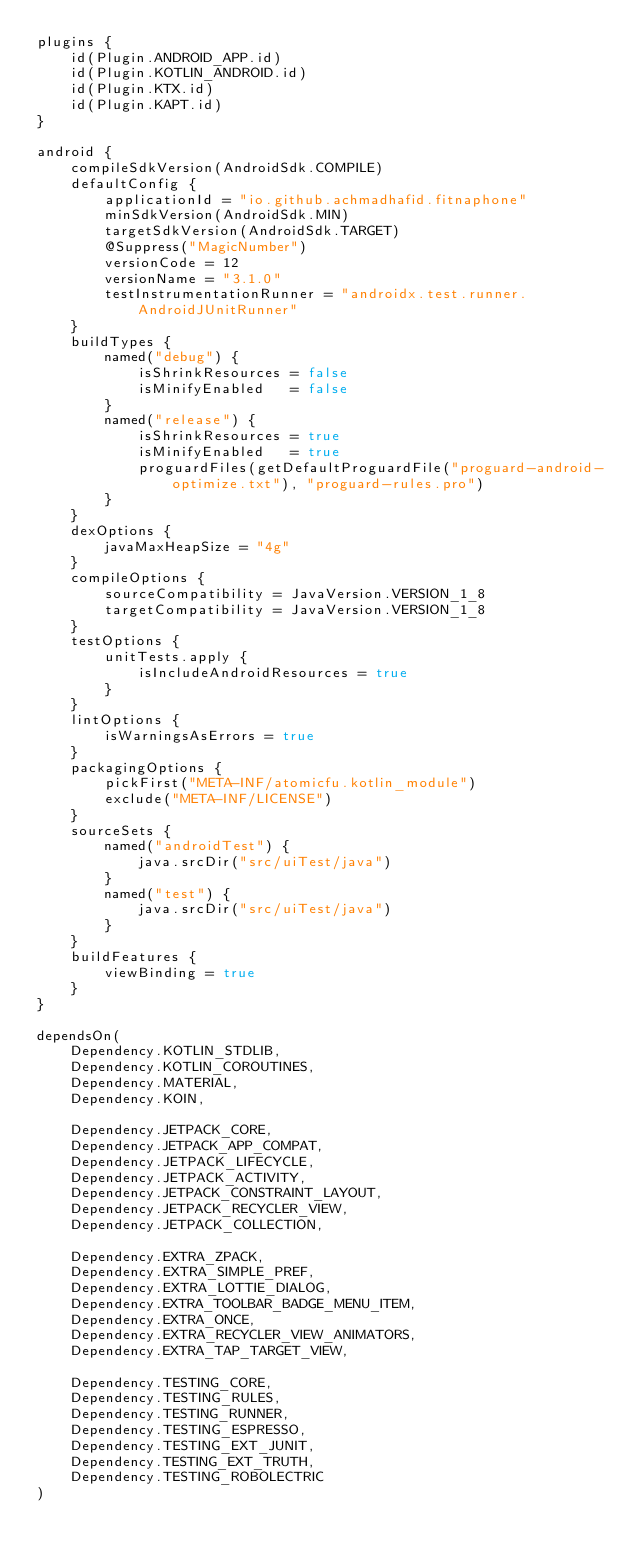Convert code to text. <code><loc_0><loc_0><loc_500><loc_500><_Kotlin_>plugins {
    id(Plugin.ANDROID_APP.id)
    id(Plugin.KOTLIN_ANDROID.id)
    id(Plugin.KTX.id)
    id(Plugin.KAPT.id)
}

android {
    compileSdkVersion(AndroidSdk.COMPILE)
    defaultConfig {
        applicationId = "io.github.achmadhafid.fitnaphone"
        minSdkVersion(AndroidSdk.MIN)
        targetSdkVersion(AndroidSdk.TARGET)
        @Suppress("MagicNumber")
        versionCode = 12
        versionName = "3.1.0"
        testInstrumentationRunner = "androidx.test.runner.AndroidJUnitRunner"
    }
    buildTypes {
        named("debug") {
            isShrinkResources = false
            isMinifyEnabled   = false
        }
        named("release") {
            isShrinkResources = true
            isMinifyEnabled   = true
            proguardFiles(getDefaultProguardFile("proguard-android-optimize.txt"), "proguard-rules.pro")
        }
    }
    dexOptions {
        javaMaxHeapSize = "4g"
    }
    compileOptions {
        sourceCompatibility = JavaVersion.VERSION_1_8
        targetCompatibility = JavaVersion.VERSION_1_8
    }
    testOptions {
        unitTests.apply {
            isIncludeAndroidResources = true
        }
    }
    lintOptions {
        isWarningsAsErrors = true
    }
    packagingOptions {
        pickFirst("META-INF/atomicfu.kotlin_module")
        exclude("META-INF/LICENSE")
    }
    sourceSets {
        named("androidTest") {
            java.srcDir("src/uiTest/java")
        }
        named("test") {
            java.srcDir("src/uiTest/java")
        }
    }
    buildFeatures {
        viewBinding = true
    }
}

dependsOn(
    Dependency.KOTLIN_STDLIB,
    Dependency.KOTLIN_COROUTINES,
    Dependency.MATERIAL,
    Dependency.KOIN,

    Dependency.JETPACK_CORE,
    Dependency.JETPACK_APP_COMPAT,
    Dependency.JETPACK_LIFECYCLE,
    Dependency.JETPACK_ACTIVITY,
    Dependency.JETPACK_CONSTRAINT_LAYOUT,
    Dependency.JETPACK_RECYCLER_VIEW,
    Dependency.JETPACK_COLLECTION,

    Dependency.EXTRA_ZPACK,
    Dependency.EXTRA_SIMPLE_PREF,
    Dependency.EXTRA_LOTTIE_DIALOG,
    Dependency.EXTRA_TOOLBAR_BADGE_MENU_ITEM,
    Dependency.EXTRA_ONCE,
    Dependency.EXTRA_RECYCLER_VIEW_ANIMATORS,
    Dependency.EXTRA_TAP_TARGET_VIEW,

    Dependency.TESTING_CORE,
    Dependency.TESTING_RULES,
    Dependency.TESTING_RUNNER,
    Dependency.TESTING_ESPRESSO,
    Dependency.TESTING_EXT_JUNIT,
    Dependency.TESTING_EXT_TRUTH,
    Dependency.TESTING_ROBOLECTRIC
)
</code> 